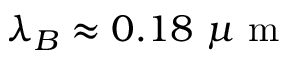Convert formula to latex. <formula><loc_0><loc_0><loc_500><loc_500>\lambda _ { B } \approx 0 . 1 8 \mu m</formula> 